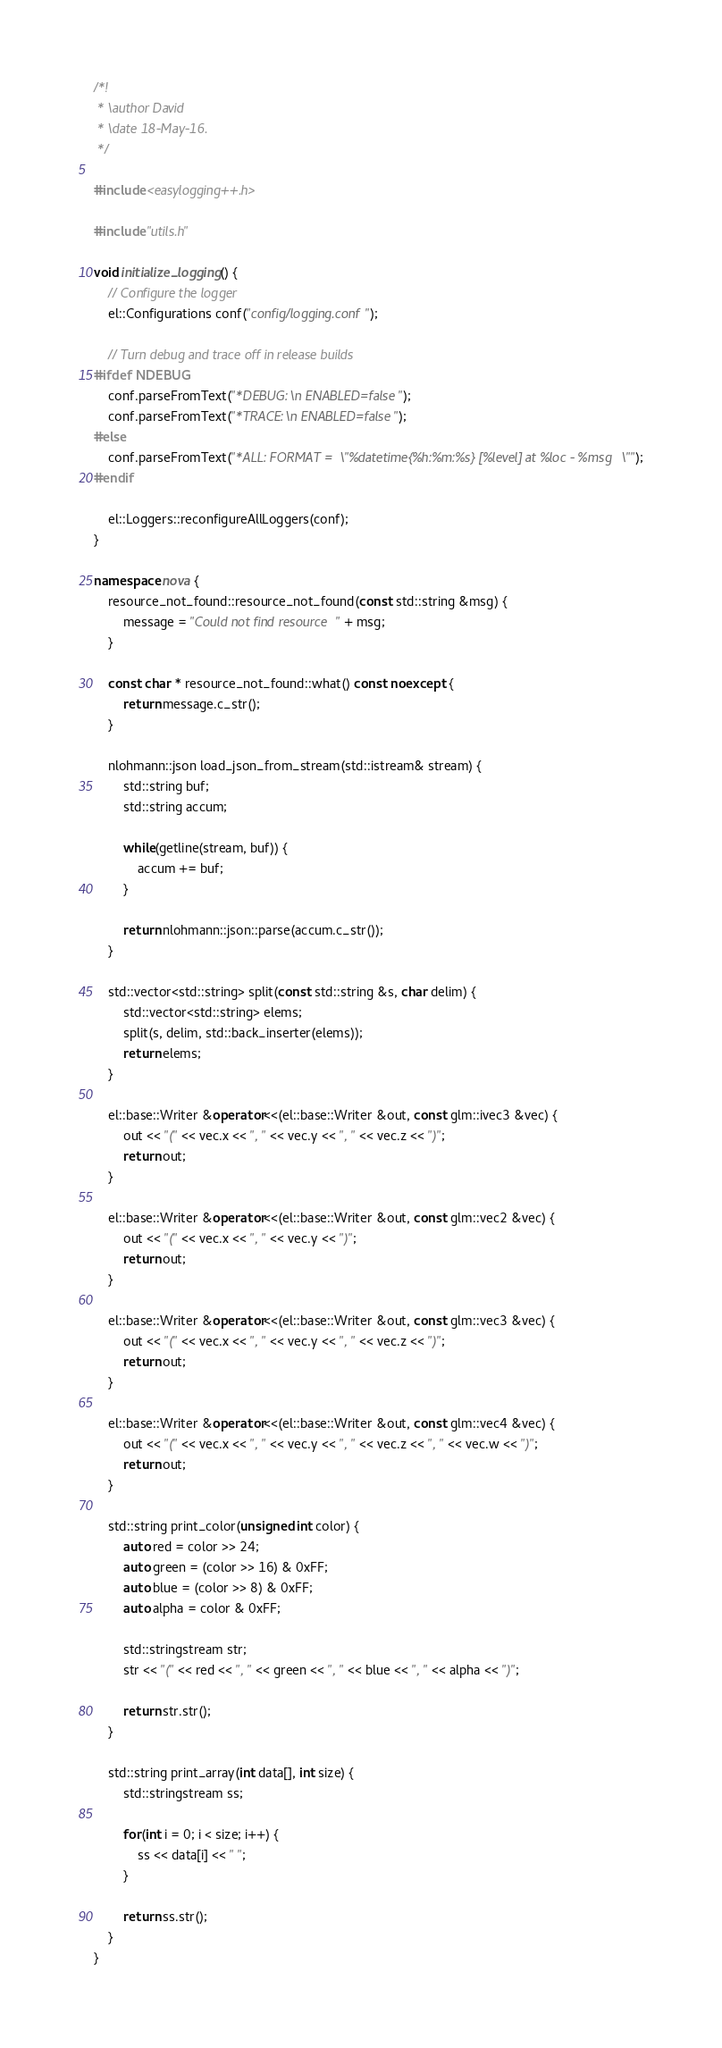<code> <loc_0><loc_0><loc_500><loc_500><_C++_>/*!
 * \author David
 * \date 18-May-16.
 */

#include <easylogging++.h>

#include "utils.h"

void initialize_logging() {
    // Configure the logger
    el::Configurations conf("config/logging.conf");

    // Turn debug and trace off in release builds
#ifdef NDEBUG
    conf.parseFromText("*DEBUG:\n ENABLED=false");
    conf.parseFromText("*TRACE:\n ENABLED=false");
#else
    conf.parseFromText("*ALL: FORMAT = \"%datetime{%h:%m:%s} [%level] at %loc - %msg\"");
#endif

    el::Loggers::reconfigureAllLoggers(conf);
}

namespace nova {
    resource_not_found::resource_not_found(const std::string &msg) {
        message = "Could not find resource " + msg;
    }

    const char * resource_not_found::what() const noexcept {
        return message.c_str();
    }

    nlohmann::json load_json_from_stream(std::istream& stream) {
        std::string buf;
        std::string accum;

        while(getline(stream, buf)) {
            accum += buf;
        }

        return nlohmann::json::parse(accum.c_str());
    }

    std::vector<std::string> split(const std::string &s, char delim) {
        std::vector<std::string> elems;
        split(s, delim, std::back_inserter(elems));
        return elems;
    }

    el::base::Writer &operator<<(el::base::Writer &out, const glm::ivec3 &vec) {
        out << "(" << vec.x << ", " << vec.y << ", " << vec.z << ")";
        return out;
    }

    el::base::Writer &operator<<(el::base::Writer &out, const glm::vec2 &vec) {
        out << "(" << vec.x << ", " << vec.y << ")";
        return out;
    }

    el::base::Writer &operator<<(el::base::Writer &out, const glm::vec3 &vec) {
        out << "(" << vec.x << ", " << vec.y << ", " << vec.z << ")";
        return out;
    }

    el::base::Writer &operator<<(el::base::Writer &out, const glm::vec4 &vec) {
        out << "(" << vec.x << ", " << vec.y << ", " << vec.z << ", " << vec.w << ")";
        return out;
    }

    std::string print_color(unsigned int color) {
        auto red = color >> 24;
        auto green = (color >> 16) & 0xFF;
        auto blue = (color >> 8) & 0xFF;
        auto alpha = color & 0xFF;

        std::stringstream str;
        str << "(" << red << ", " << green << ", " << blue << ", " << alpha << ")";

        return str.str();
    }

    std::string print_array(int data[], int size) {
        std::stringstream ss;

        for(int i = 0; i < size; i++) {
            ss << data[i] << " ";
        }

        return ss.str();
    }
}

</code> 